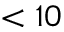Convert formula to latex. <formula><loc_0><loc_0><loc_500><loc_500>< 1 0</formula> 